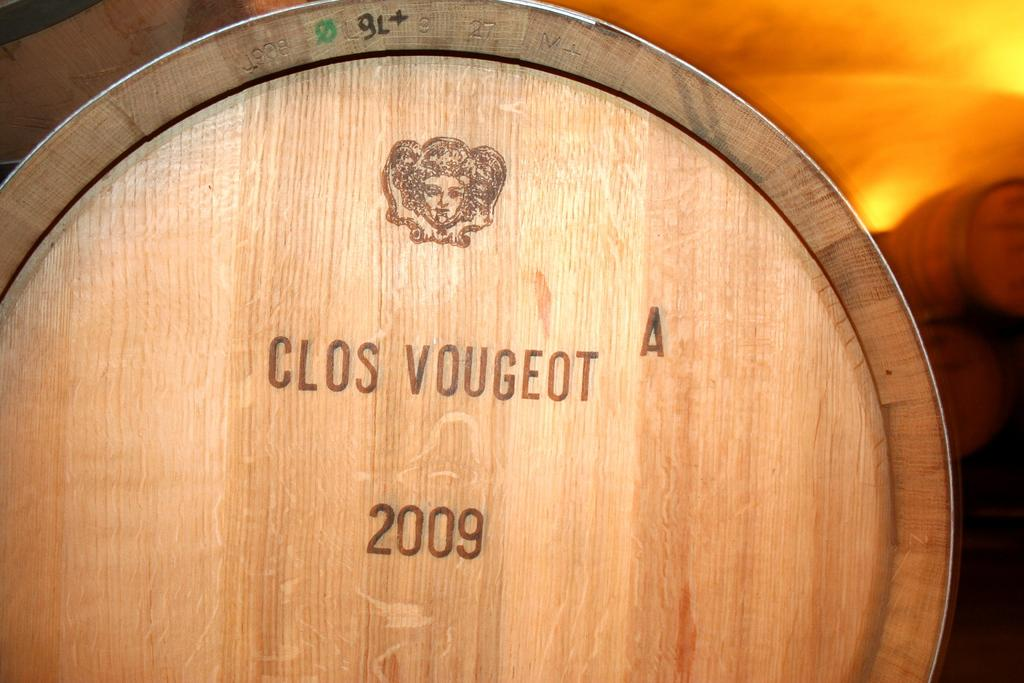Provide a one-sentence caption for the provided image. A woode barrel that was sealed in the year 2009. 